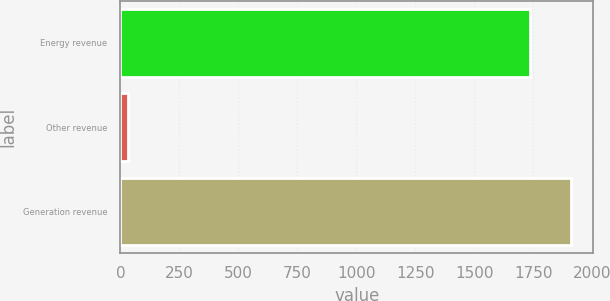<chart> <loc_0><loc_0><loc_500><loc_500><bar_chart><fcel>Energy revenue<fcel>Other revenue<fcel>Generation revenue<nl><fcel>1735<fcel>30<fcel>1909.9<nl></chart> 